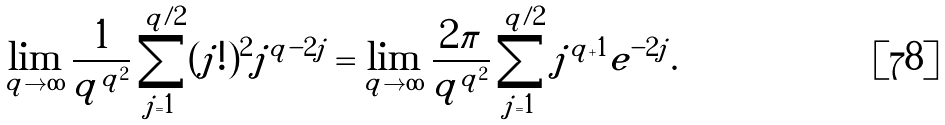Convert formula to latex. <formula><loc_0><loc_0><loc_500><loc_500>\lim _ { q \to \infty } \frac { 1 } { q ^ { q ^ { 2 } } } \sum _ { j = 1 } ^ { q / 2 } ( j ! ) ^ { 2 } j ^ { q - 2 j } = \lim _ { q \to \infty } \frac { 2 \pi } { q ^ { q ^ { 2 } } } \sum _ { j = 1 } ^ { q / 2 } j ^ { q + 1 } e ^ { - 2 j } .</formula> 